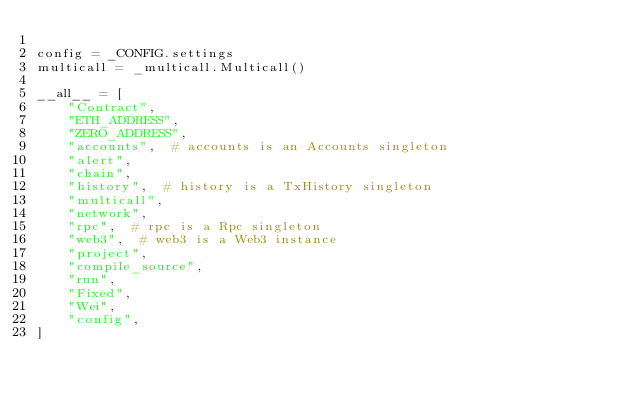Convert code to text. <code><loc_0><loc_0><loc_500><loc_500><_Python_>
config = _CONFIG.settings
multicall = _multicall.Multicall()

__all__ = [
    "Contract",
    "ETH_ADDRESS",
    "ZERO_ADDRESS",
    "accounts",  # accounts is an Accounts singleton
    "alert",
    "chain",
    "history",  # history is a TxHistory singleton
    "multicall",
    "network",
    "rpc",  # rpc is a Rpc singleton
    "web3",  # web3 is a Web3 instance
    "project",
    "compile_source",
    "run",
    "Fixed",
    "Wei",
    "config",
]
</code> 